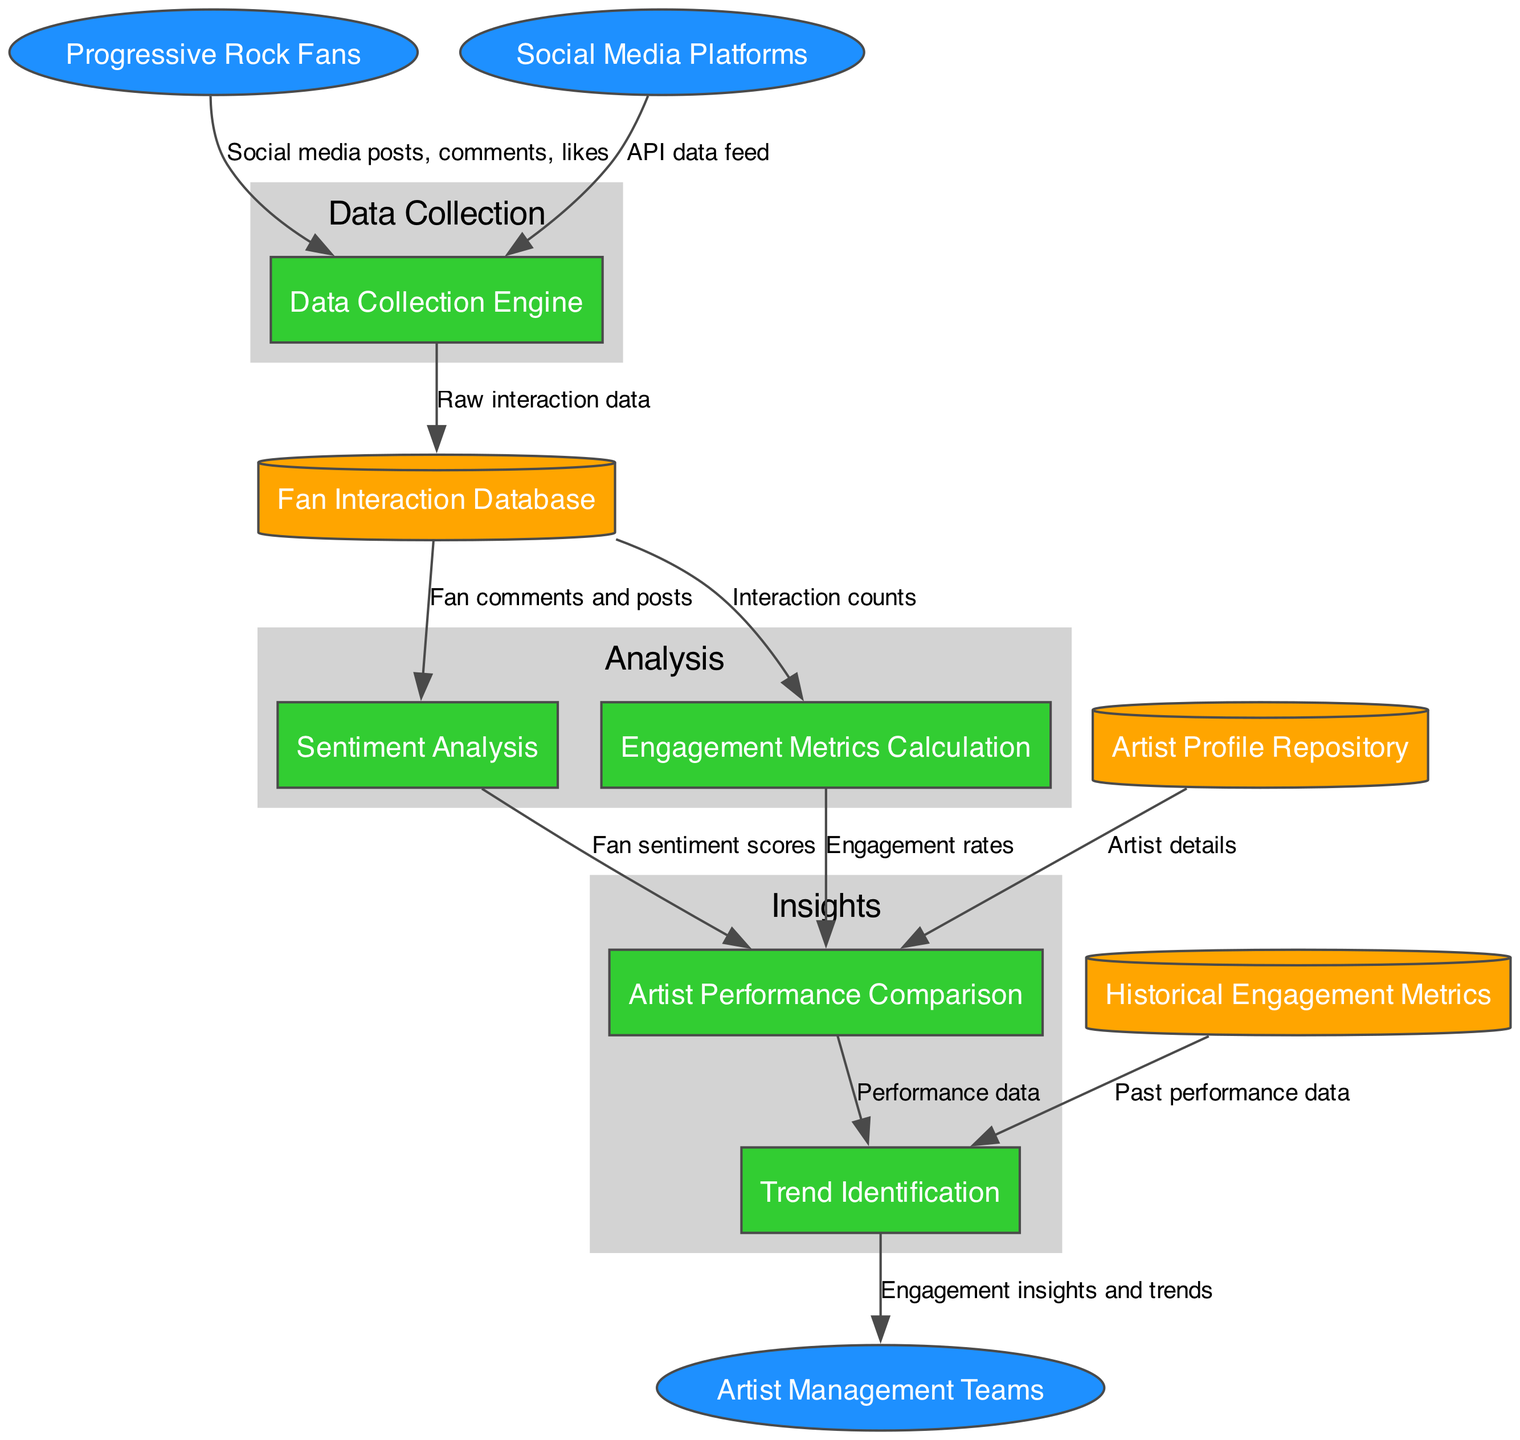What are the external entities in the diagram? The diagram lists three external entities: Progressive Rock Fans, Artist Management Teams, and Social Media Platforms. Each of these entities interacts with the processes in the system.
Answer: Progressive Rock Fans, Artist Management Teams, Social Media Platforms How many processes are shown in the diagram? There are five distinct processes identified in the diagram: Data Collection Engine, Sentiment Analysis, Engagement Metrics Calculation, Artist Performance Comparison, and Trend Identification. By counting them, we find the total.
Answer: 5 What type of data does the Data Collection Engine receive from Social Media Platforms? The relationship between the Social Media Platforms and the Data Collection Engine is indicated by an arrow labeled "API data feed," representing the type of data transferred.
Answer: API data feed Which process receives fan comments and posts? The flow of data originating from the Fan Interaction Database is directed towards the Sentiment Analysis process, which clearly indicates that it processes fan comments and posts.
Answer: Sentiment Analysis What information is transferred from the Engagement Metrics Calculation to the Artist Performance Comparison? The arrow between Engagement Metrics Calculation and Artist Performance Comparison is labeled "Engagement rates," suggesting that this specific type of information is passed along in this flow.
Answer: Engagement rates What are the insights and trends delivered to? The flow from Trend Identification culminates in delivering insights and trends to Artist Management Teams, as indicated by the arrow at the end of the data flow.
Answer: Artist Management Teams How many data flows are there between processes and external entities? By counting all arrows connecting external entities to processes, as well as those between processes themselves, we find the total number of data flows in the diagram.
Answer: 11 Which data store provides historical performance data to the Trend Identification process? The Historical Engagement Metrics data store is distinctly connected to the Trend Identification process, conveying the historical performance data utilized for trend analysis.
Answer: Historical Engagement Metrics What type of data is stored in the Fan Interaction Database? The data flowing from the Data Collection Engine into the Fan Interaction Database is labeled as "Raw interaction data," which explicitly indicates the type of information stored within it.
Answer: Raw interaction data 